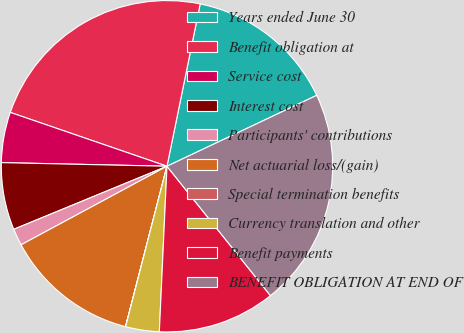Convert chart. <chart><loc_0><loc_0><loc_500><loc_500><pie_chart><fcel>Years ended June 30<fcel>Benefit obligation at<fcel>Service cost<fcel>Interest cost<fcel>Participants' contributions<fcel>Net actuarial loss/(gain)<fcel>Special termination benefits<fcel>Currency translation and other<fcel>Benefit payments<fcel>BENEFIT OBLIGATION AT END OF<nl><fcel>14.75%<fcel>22.94%<fcel>4.92%<fcel>6.56%<fcel>1.65%<fcel>13.11%<fcel>0.01%<fcel>3.28%<fcel>11.47%<fcel>21.3%<nl></chart> 